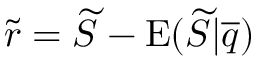Convert formula to latex. <formula><loc_0><loc_0><loc_500><loc_500>\widetilde { r } = \widetilde { S } - E ( \widetilde { S } | \overline { q } )</formula> 